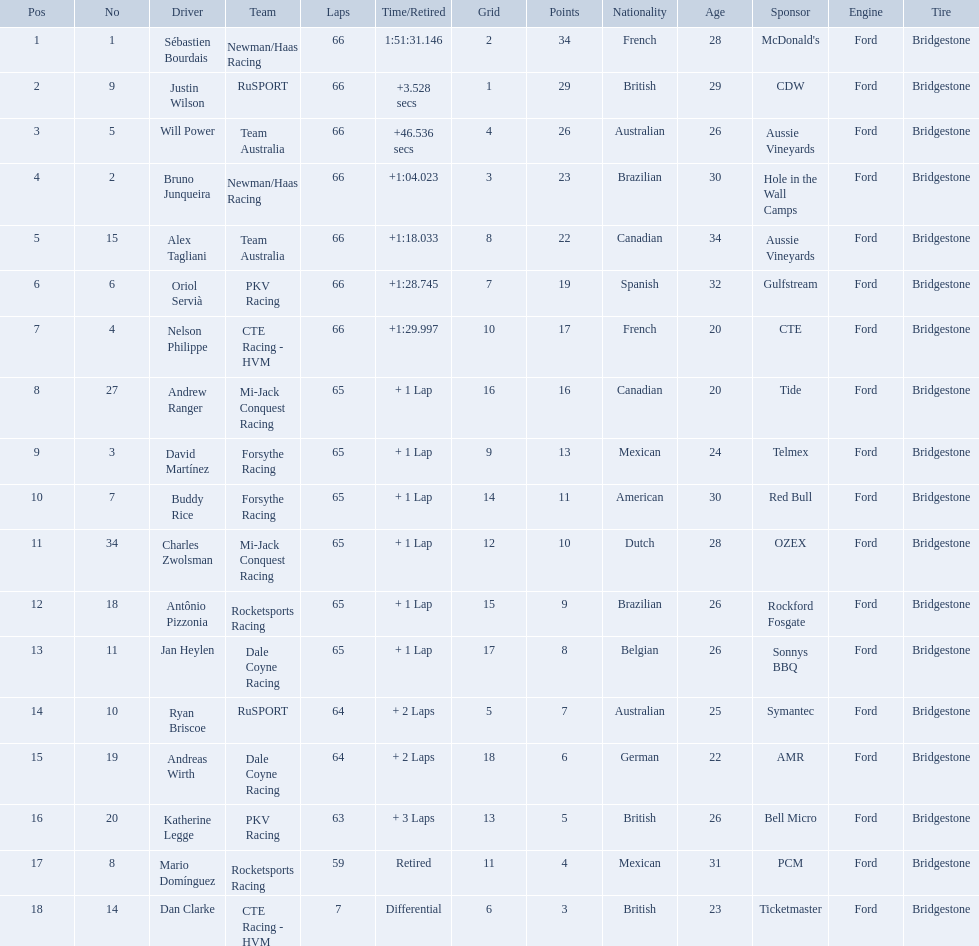What was the highest amount of points scored in the 2006 gran premio? 34. Who scored 34 points? Sébastien Bourdais. Which drivers scored at least 10 points? Sébastien Bourdais, Justin Wilson, Will Power, Bruno Junqueira, Alex Tagliani, Oriol Servià, Nelson Philippe, Andrew Ranger, David Martínez, Buddy Rice, Charles Zwolsman. Of those drivers, which ones scored at least 20 points? Sébastien Bourdais, Justin Wilson, Will Power, Bruno Junqueira, Alex Tagliani. Of those 5, which driver scored the most points? Sébastien Bourdais. What are the drivers numbers? 1, 9, 5, 2, 15, 6, 4, 27, 3, 7, 34, 18, 11, 10, 19, 20, 8, 14. Are there any who's number matches his position? Sébastien Bourdais, Oriol Servià. Could you parse the entire table? {'header': ['Pos', 'No', 'Driver', 'Team', 'Laps', 'Time/Retired', 'Grid', 'Points', 'Nationality', 'Age', 'Sponsor', 'Engine', 'Tire'], 'rows': [['1', '1', 'Sébastien Bourdais', 'Newman/Haas Racing', '66', '1:51:31.146', '2', '34', 'French', '28', "McDonald's", 'Ford', 'Bridgestone'], ['2', '9', 'Justin Wilson', 'RuSPORT', '66', '+3.528 secs', '1', '29', 'British', '29', 'CDW', 'Ford', 'Bridgestone'], ['3', '5', 'Will Power', 'Team Australia', '66', '+46.536 secs', '4', '26', 'Australian', '26', 'Aussie Vineyards', 'Ford', 'Bridgestone'], ['4', '2', 'Bruno Junqueira', 'Newman/Haas Racing', '66', '+1:04.023', '3', '23', 'Brazilian', '30', 'Hole in the Wall Camps', 'Ford', 'Bridgestone'], ['5', '15', 'Alex Tagliani', 'Team Australia', '66', '+1:18.033', '8', '22', 'Canadian', '34', 'Aussie Vineyards', 'Ford', 'Bridgestone'], ['6', '6', 'Oriol Servià', 'PKV Racing', '66', '+1:28.745', '7', '19', 'Spanish', '32', 'Gulfstream', 'Ford', 'Bridgestone'], ['7', '4', 'Nelson Philippe', 'CTE Racing - HVM', '66', '+1:29.997', '10', '17', 'French', '20', 'CTE', 'Ford', 'Bridgestone'], ['8', '27', 'Andrew Ranger', 'Mi-Jack Conquest Racing', '65', '+ 1 Lap', '16', '16', 'Canadian', '20', 'Tide', 'Ford', 'Bridgestone'], ['9', '3', 'David Martínez', 'Forsythe Racing', '65', '+ 1 Lap', '9', '13', 'Mexican', '24', 'Telmex', 'Ford', 'Bridgestone'], ['10', '7', 'Buddy Rice', 'Forsythe Racing', '65', '+ 1 Lap', '14', '11', 'American', '30', 'Red Bull', 'Ford', 'Bridgestone'], ['11', '34', 'Charles Zwolsman', 'Mi-Jack Conquest Racing', '65', '+ 1 Lap', '12', '10', 'Dutch', '28', 'OZEX', 'Ford', 'Bridgestone'], ['12', '18', 'Antônio Pizzonia', 'Rocketsports Racing', '65', '+ 1 Lap', '15', '9', 'Brazilian', '26', 'Rockford Fosgate', 'Ford', 'Bridgestone'], ['13', '11', 'Jan Heylen', 'Dale Coyne Racing', '65', '+ 1 Lap', '17', '8', 'Belgian', '26', 'Sonnys BBQ', 'Ford', 'Bridgestone'], ['14', '10', 'Ryan Briscoe', 'RuSPORT', '64', '+ 2 Laps', '5', '7', 'Australian', '25', 'Symantec', 'Ford', 'Bridgestone'], ['15', '19', 'Andreas Wirth', 'Dale Coyne Racing', '64', '+ 2 Laps', '18', '6', 'German', '22', 'AMR', 'Ford', 'Bridgestone'], ['16', '20', 'Katherine Legge', 'PKV Racing', '63', '+ 3 Laps', '13', '5', 'British', '26', 'Bell Micro', 'Ford', 'Bridgestone'], ['17', '8', 'Mario Domínguez', 'Rocketsports Racing', '59', 'Retired', '11', '4', 'Mexican', '31', 'PCM', 'Ford', 'Bridgestone'], ['18', '14', 'Dan Clarke', 'CTE Racing - HVM', '7', 'Differential', '6', '3', 'British', '23', 'Ticketmaster', 'Ford', 'Bridgestone']]} Of those two who has the highest position? Sébastien Bourdais. Who are the drivers? Sébastien Bourdais, Justin Wilson, Will Power, Bruno Junqueira, Alex Tagliani, Oriol Servià, Nelson Philippe, Andrew Ranger, David Martínez, Buddy Rice, Charles Zwolsman, Antônio Pizzonia, Jan Heylen, Ryan Briscoe, Andreas Wirth, Katherine Legge, Mario Domínguez, Dan Clarke. What are their numbers? 1, 9, 5, 2, 15, 6, 4, 27, 3, 7, 34, 18, 11, 10, 19, 20, 8, 14. What are their positions? 1, 2, 3, 4, 5, 6, 7, 8, 9, 10, 11, 12, 13, 14, 15, 16, 17, 18. Which driver has the same number and position? Sébastien Bourdais. 